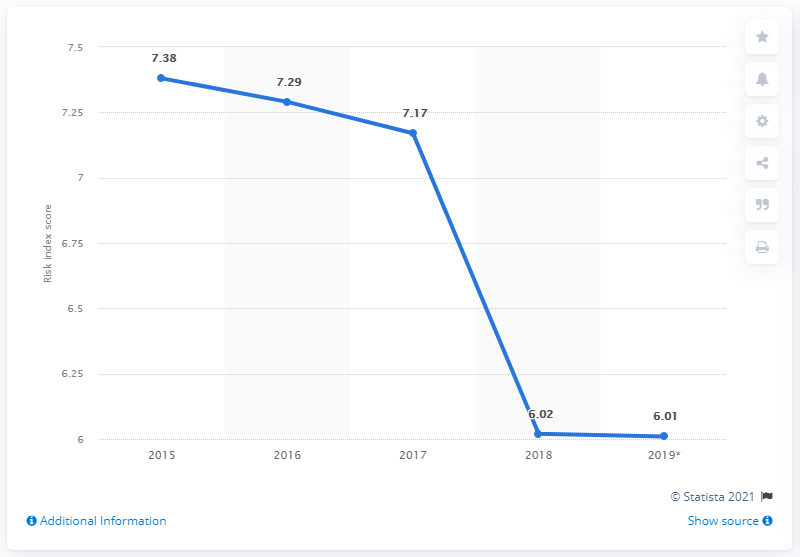Mention a couple of crucial points in this snapshot. In 2019, Bolivia scored 6.01 goals. The sum of the 2018 and 2017 risk index scores is greater than the 2015 risk index score. In 2019, the risk index score was the lowest among all the years considered. Bolivia's risk index showed a downward trend in 2015. 